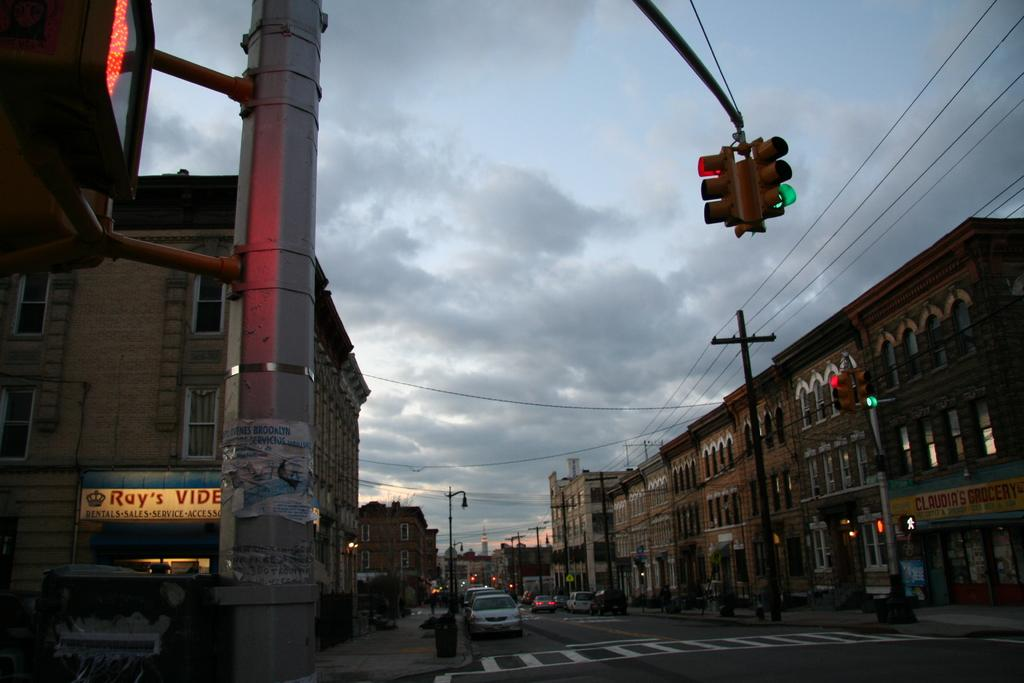Provide a one-sentence caption for the provided image. A downtown scene displaying Roy's video store at night. 